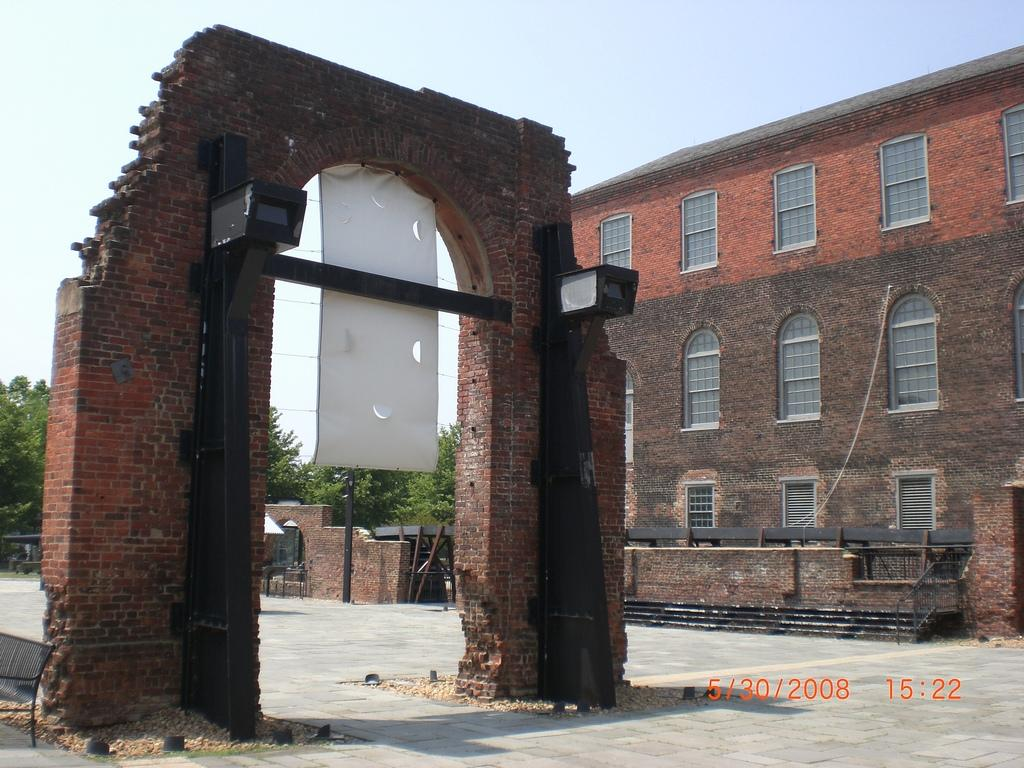What type of structure can be seen in the image? There is an arch in the image. What other objects are present near the arch? There are poles and a banner visible in the image. What can be seen in the background of the image? There are walls, ground, buildings, windows, trees, and the sky visible in the background of the image. Can you describe the chair in the image? There is a chair in the image. What other objects can be seen in the image? There are objects in the image, but their specific details are not mentioned in the facts. How many suits and gloves are hanging from the spiders in the image? There are no spiders, suits, or gloves present in the image. 